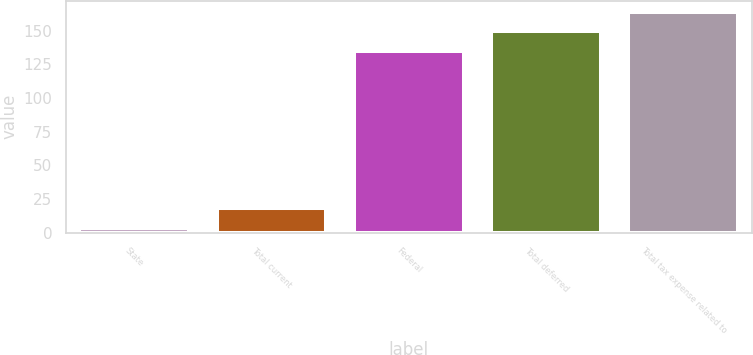Convert chart. <chart><loc_0><loc_0><loc_500><loc_500><bar_chart><fcel>State<fcel>Total current<fcel>Federal<fcel>Total deferred<fcel>Total tax expense related to<nl><fcel>3.5<fcel>18.07<fcel>134.9<fcel>149.47<fcel>164.04<nl></chart> 